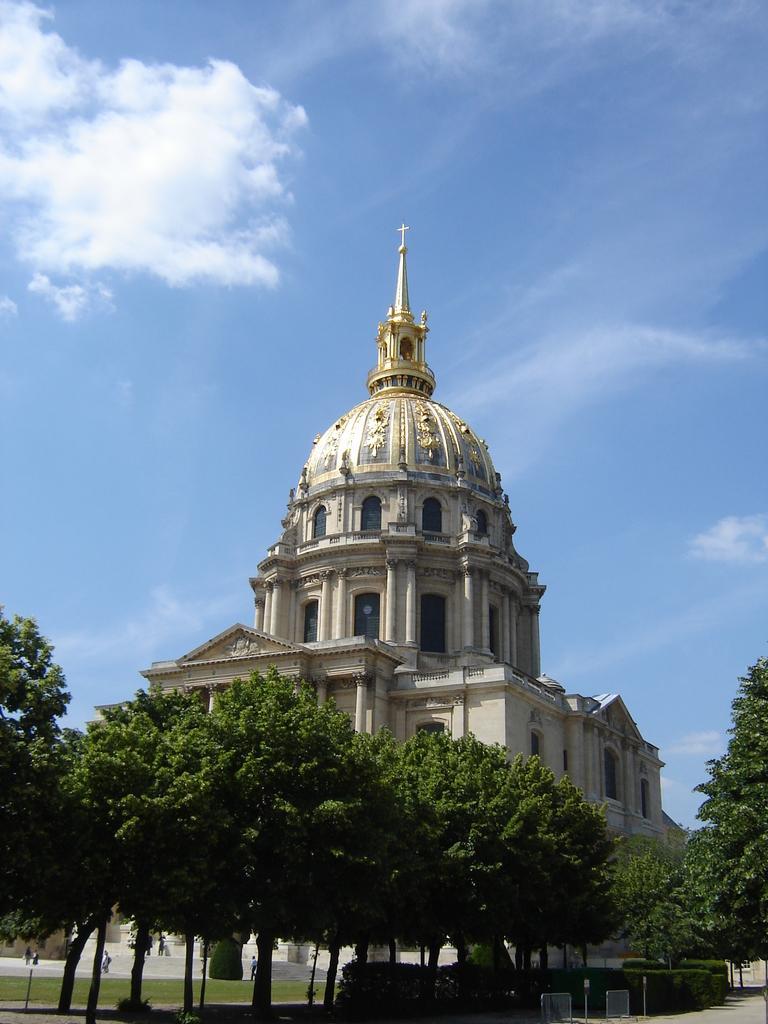Can you describe this image briefly? On the right side of the image there is a road. There are plants. There are boards. There are trees. In the center of the image there is a building. On the left side of the image there is grass on the surface. In front of the building there are people. In the background of the image there is sky. 